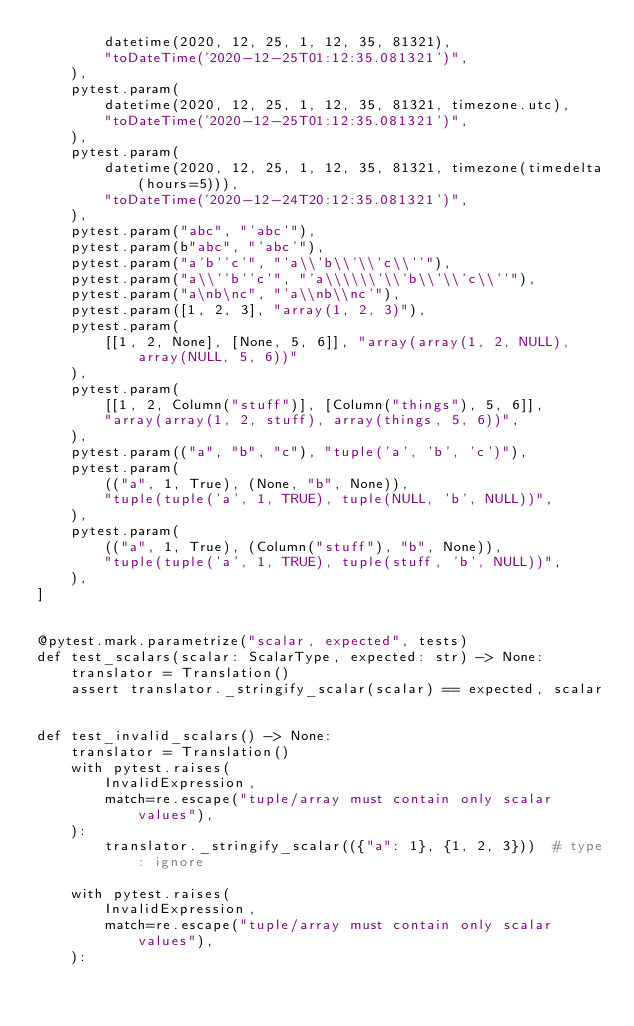Convert code to text. <code><loc_0><loc_0><loc_500><loc_500><_Python_>        datetime(2020, 12, 25, 1, 12, 35, 81321),
        "toDateTime('2020-12-25T01:12:35.081321')",
    ),
    pytest.param(
        datetime(2020, 12, 25, 1, 12, 35, 81321, timezone.utc),
        "toDateTime('2020-12-25T01:12:35.081321')",
    ),
    pytest.param(
        datetime(2020, 12, 25, 1, 12, 35, 81321, timezone(timedelta(hours=5))),
        "toDateTime('2020-12-24T20:12:35.081321')",
    ),
    pytest.param("abc", "'abc'"),
    pytest.param(b"abc", "'abc'"),
    pytest.param("a'b''c'", "'a\\'b\\'\\'c\\''"),
    pytest.param("a\\''b''c'", "'a\\\\\\'\\'b\\'\\'c\\''"),
    pytest.param("a\nb\nc", "'a\\nb\\nc'"),
    pytest.param([1, 2, 3], "array(1, 2, 3)"),
    pytest.param(
        [[1, 2, None], [None, 5, 6]], "array(array(1, 2, NULL), array(NULL, 5, 6))"
    ),
    pytest.param(
        [[1, 2, Column("stuff")], [Column("things"), 5, 6]],
        "array(array(1, 2, stuff), array(things, 5, 6))",
    ),
    pytest.param(("a", "b", "c"), "tuple('a', 'b', 'c')"),
    pytest.param(
        (("a", 1, True), (None, "b", None)),
        "tuple(tuple('a', 1, TRUE), tuple(NULL, 'b', NULL))",
    ),
    pytest.param(
        (("a", 1, True), (Column("stuff"), "b", None)),
        "tuple(tuple('a', 1, TRUE), tuple(stuff, 'b', NULL))",
    ),
]


@pytest.mark.parametrize("scalar, expected", tests)
def test_scalars(scalar: ScalarType, expected: str) -> None:
    translator = Translation()
    assert translator._stringify_scalar(scalar) == expected, scalar


def test_invalid_scalars() -> None:
    translator = Translation()
    with pytest.raises(
        InvalidExpression,
        match=re.escape("tuple/array must contain only scalar values"),
    ):
        translator._stringify_scalar(({"a": 1}, {1, 2, 3}))  # type: ignore

    with pytest.raises(
        InvalidExpression,
        match=re.escape("tuple/array must contain only scalar values"),
    ):</code> 